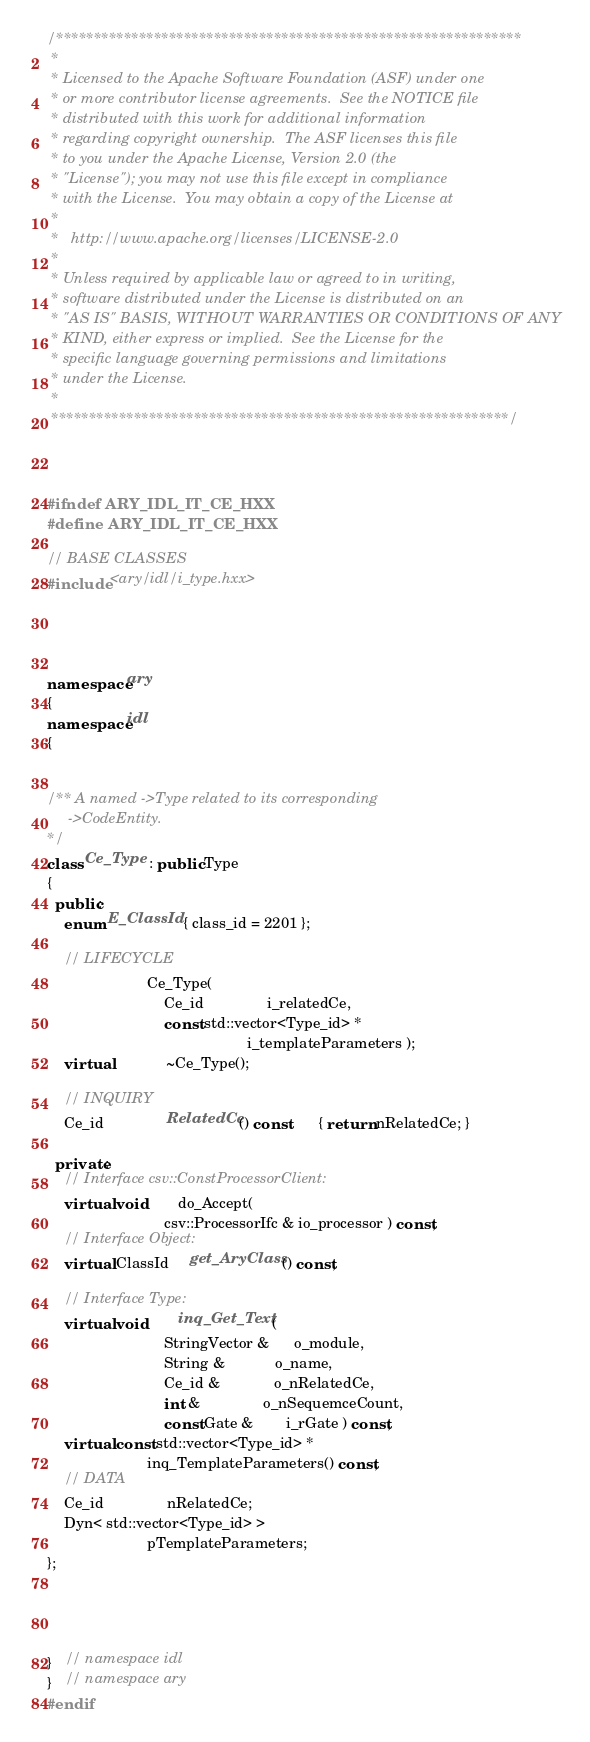<code> <loc_0><loc_0><loc_500><loc_500><_C++_>/**************************************************************
 * 
 * Licensed to the Apache Software Foundation (ASF) under one
 * or more contributor license agreements.  See the NOTICE file
 * distributed with this work for additional information
 * regarding copyright ownership.  The ASF licenses this file
 * to you under the Apache License, Version 2.0 (the
 * "License"); you may not use this file except in compliance
 * with the License.  You may obtain a copy of the License at
 * 
 *   http://www.apache.org/licenses/LICENSE-2.0
 * 
 * Unless required by applicable law or agreed to in writing,
 * software distributed under the License is distributed on an
 * "AS IS" BASIS, WITHOUT WARRANTIES OR CONDITIONS OF ANY
 * KIND, either express or implied.  See the License for the
 * specific language governing permissions and limitations
 * under the License.
 * 
 *************************************************************/



#ifndef ARY_IDL_IT_CE_HXX
#define ARY_IDL_IT_CE_HXX

// BASE CLASSES
#include <ary/idl/i_type.hxx>




namespace ary
{
namespace idl
{


/** A named ->Type related to its corresponding
     ->CodeEntity.
*/
class Ce_Type : public Type
{
  public:
    enum E_ClassId { class_id = 2201 };

    // LIFECYCLE
                        Ce_Type(
                            Ce_id               i_relatedCe,
                            const std::vector<Type_id> *
                                                i_templateParameters );
    virtual             ~Ce_Type();

    // INQUIRY
    Ce_id               RelatedCe() const       { return nRelatedCe; }

  private:
    // Interface csv::ConstProcessorClient:
    virtual void        do_Accept(
                            csv::ProcessorIfc & io_processor ) const;
    // Interface Object:
    virtual ClassId     get_AryClass() const;

    // Interface Type:
    virtual void        inq_Get_Text(
                            StringVector &      o_module,
                            String &            o_name,
                            Ce_id &             o_nRelatedCe,
                            int &               o_nSequemceCount,
                            const Gate &        i_rGate ) const;
    virtual const std::vector<Type_id> *
                        inq_TemplateParameters() const;
    // DATA
    Ce_id               nRelatedCe;
    Dyn< std::vector<Type_id> >
                        pTemplateParameters;
};




}   // namespace idl
}   // namespace ary
#endif
</code> 